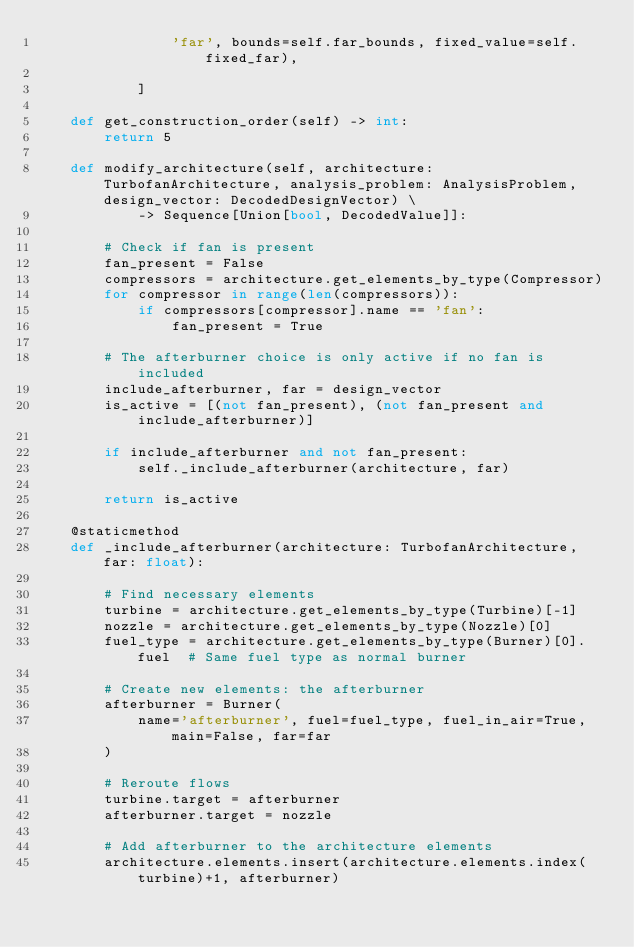Convert code to text. <code><loc_0><loc_0><loc_500><loc_500><_Python_>                'far', bounds=self.far_bounds, fixed_value=self.fixed_far),

            ]

    def get_construction_order(self) -> int:
        return 5

    def modify_architecture(self, architecture: TurbofanArchitecture, analysis_problem: AnalysisProblem, design_vector: DecodedDesignVector) \
            -> Sequence[Union[bool, DecodedValue]]:

        # Check if fan is present
        fan_present = False
        compressors = architecture.get_elements_by_type(Compressor)
        for compressor in range(len(compressors)):
            if compressors[compressor].name == 'fan':
                fan_present = True

        # The afterburner choice is only active if no fan is included
        include_afterburner, far = design_vector
        is_active = [(not fan_present), (not fan_present and include_afterburner)]

        if include_afterburner and not fan_present:
            self._include_afterburner(architecture, far)

        return is_active

    @staticmethod
    def _include_afterburner(architecture: TurbofanArchitecture, far: float):

        # Find necessary elements
        turbine = architecture.get_elements_by_type(Turbine)[-1]
        nozzle = architecture.get_elements_by_type(Nozzle)[0]
        fuel_type = architecture.get_elements_by_type(Burner)[0].fuel  # Same fuel type as normal burner

        # Create new elements: the afterburner
        afterburner = Burner(
            name='afterburner', fuel=fuel_type, fuel_in_air=True, main=False, far=far
        )

        # Reroute flows
        turbine.target = afterburner
        afterburner.target = nozzle

        # Add afterburner to the architecture elements
        architecture.elements.insert(architecture.elements.index(turbine)+1, afterburner)
</code> 